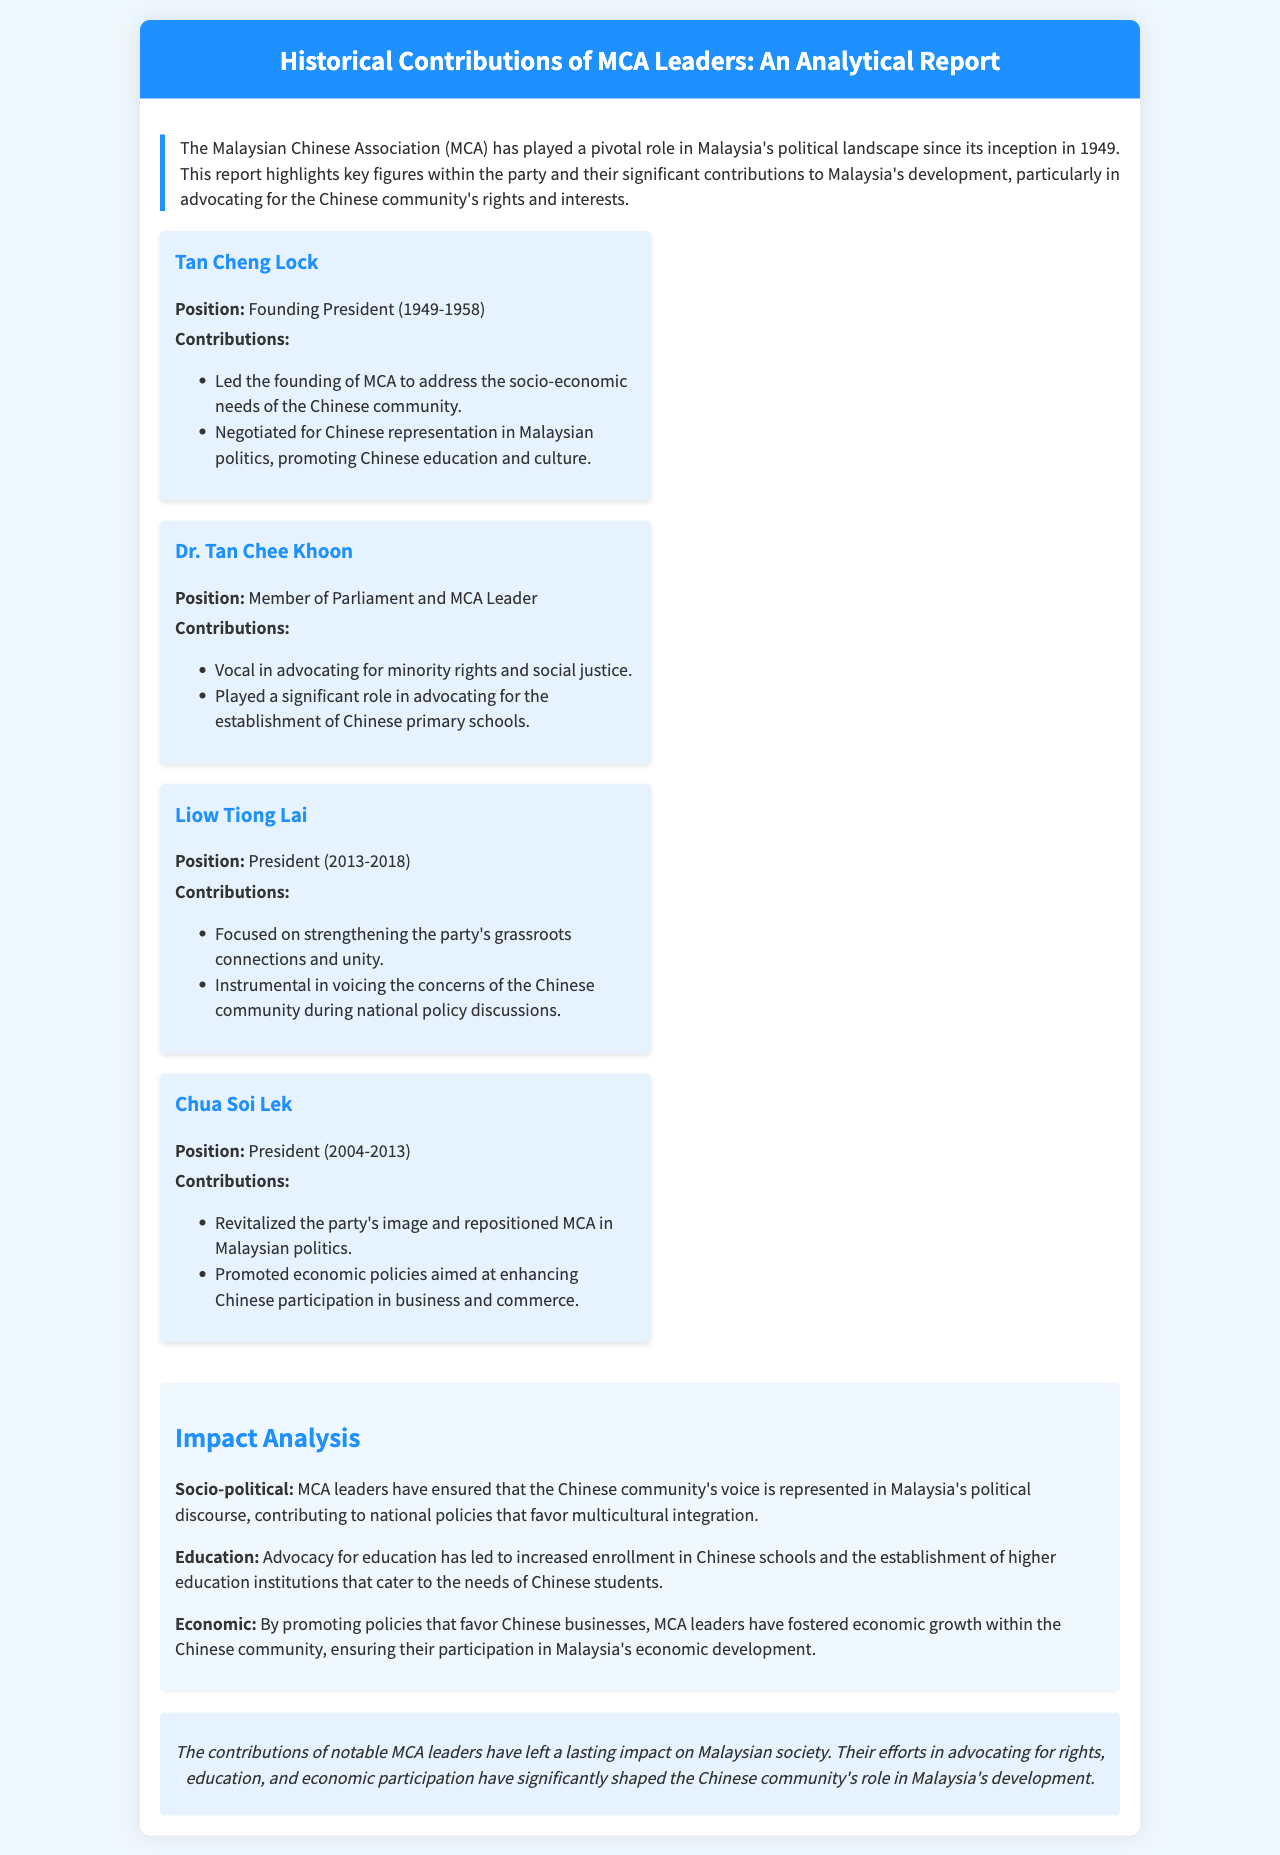What year was MCA founded? The document states that MCA was founded in 1949, which is a key historical fact about the party.
Answer: 1949 Who was the founding president of MCA? The report highlights Tan Cheng Lock as the founding president of MCA from 1949 to 1958.
Answer: Tan Cheng Lock What was Liow Tiong Lai's position in MCA? The document mentions that Liow Tiong Lai served as the president of MCA from 2013 to 2018.
Answer: President What significant contribution did Dr. Tan Chee Khoon make? According to the report, he was vocal in advocating for minority rights, which is a key aspect of his contributions.
Answer: Minority rights How did Chua Soi Lek impact MCA's image? The document indicates that he revitalized the party's image, which was crucial for its positioning in Malaysian politics.
Answer: Revitalized What primary sector did MCA leaders influence according to the impact analysis? The impact analysis describes the influence primarily in the socio-political sector.
Answer: Socio-political What educational advocacy was highlighted in the report? The report notes the increase in enrollment in Chinese schools as a result of MCA's educational advocacy.
Answer: Enrollment in Chinese schools What was a major economic contribution of MCA leaders? The document emphasizes the promotion of policies that favored Chinese businesses, contributing to economic growth.
Answer: Chinese businesses 